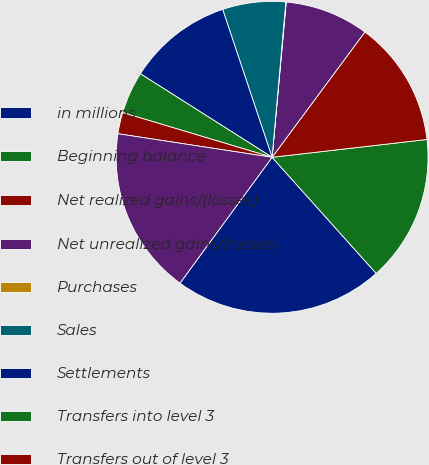Convert chart. <chart><loc_0><loc_0><loc_500><loc_500><pie_chart><fcel>in millions<fcel>Beginning balance<fcel>Net realized gains/(losses)<fcel>Net unrealized gains/(losses)<fcel>Purchases<fcel>Sales<fcel>Settlements<fcel>Transfers into level 3<fcel>Transfers out of level 3<fcel>Ending balance<nl><fcel>21.69%<fcel>15.19%<fcel>13.03%<fcel>8.7%<fcel>0.04%<fcel>6.54%<fcel>10.87%<fcel>4.37%<fcel>2.21%<fcel>17.36%<nl></chart> 